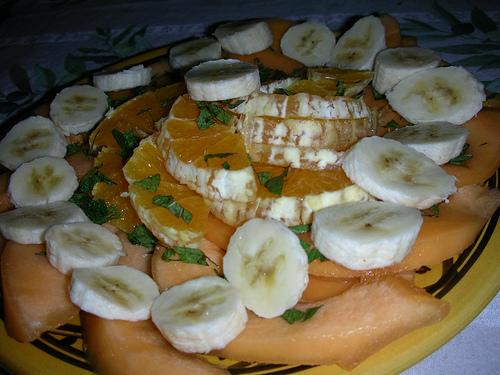Is this dish suitable for a vegetarian?
Give a very brief answer. Yes. What color is the plate?
Keep it brief. Yellow. Is this fruit cut?
Quick response, please. Yes. Are there only fruits on the plate?
Short answer required. Yes. What fruit are there besides oranges?
Short answer required. Bananas. 